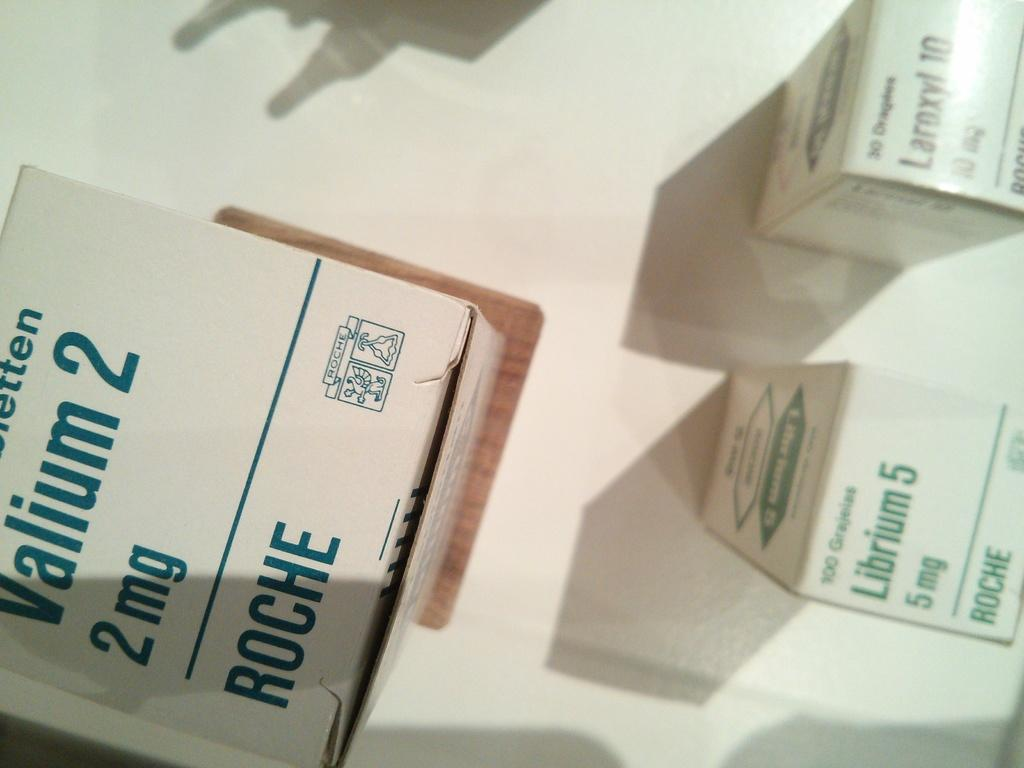<image>
Give a short and clear explanation of the subsequent image. Several boxes of medicine including Valium 2 2mg and Librium 5 5mg from Roche 